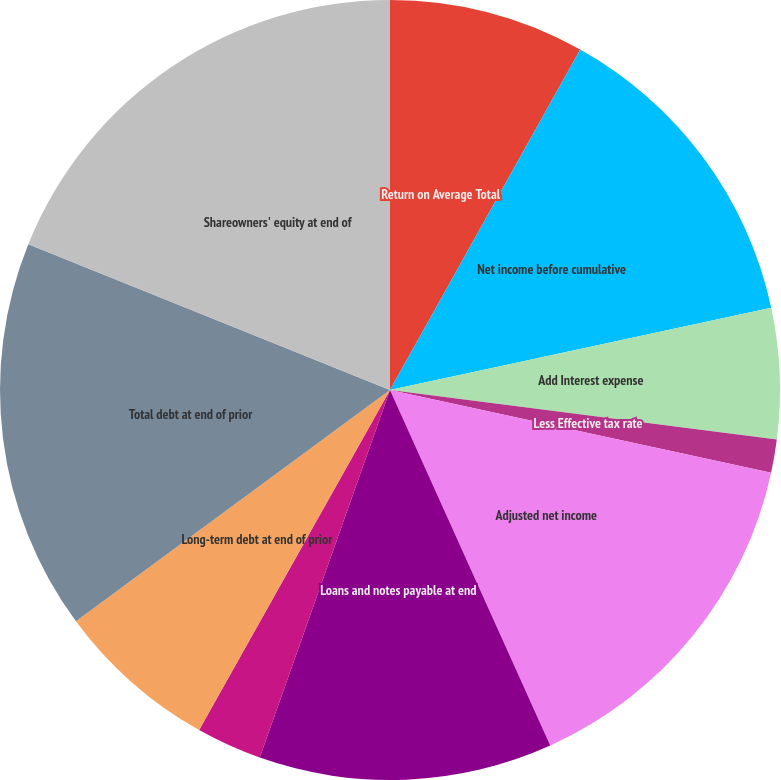Convert chart to OTSL. <chart><loc_0><loc_0><loc_500><loc_500><pie_chart><fcel>Return on Average Total<fcel>Net income before cumulative<fcel>Add Interest expense<fcel>Less Effective tax rate<fcel>Adjusted net income<fcel>Loans and notes payable at end<fcel>Current maturities of<fcel>Long-term debt at end of prior<fcel>Total debt at end of prior<fcel>Shareowners' equity at end of<nl><fcel>8.11%<fcel>13.51%<fcel>5.41%<fcel>1.37%<fcel>14.86%<fcel>12.16%<fcel>2.72%<fcel>6.76%<fcel>16.2%<fcel>18.9%<nl></chart> 